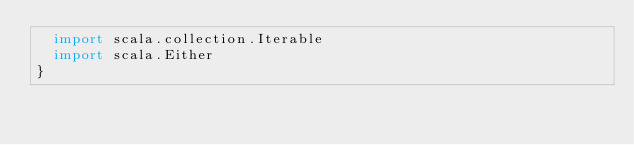<code> <loc_0><loc_0><loc_500><loc_500><_Scala_>  import scala.collection.Iterable
  import scala.Either
}
</code> 